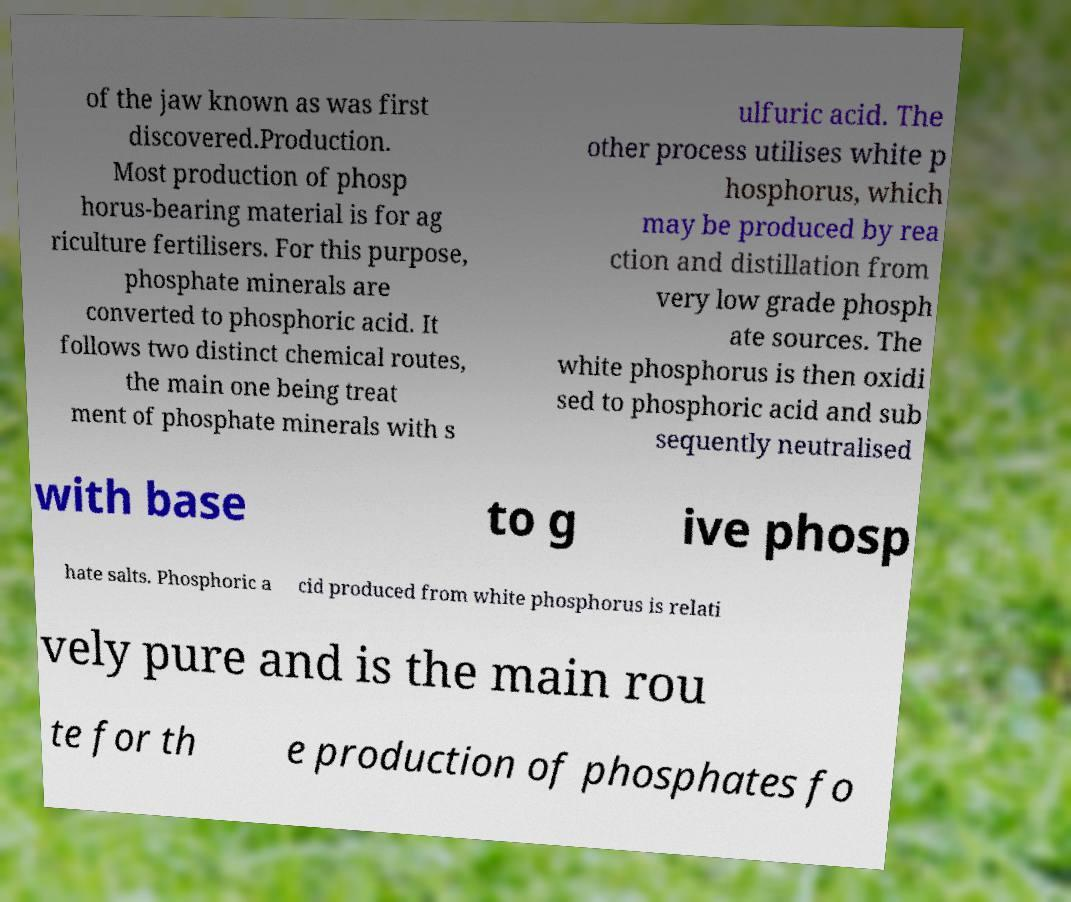There's text embedded in this image that I need extracted. Can you transcribe it verbatim? of the jaw known as was first discovered.Production. Most production of phosp horus-bearing material is for ag riculture fertilisers. For this purpose, phosphate minerals are converted to phosphoric acid. It follows two distinct chemical routes, the main one being treat ment of phosphate minerals with s ulfuric acid. The other process utilises white p hosphorus, which may be produced by rea ction and distillation from very low grade phosph ate sources. The white phosphorus is then oxidi sed to phosphoric acid and sub sequently neutralised with base to g ive phosp hate salts. Phosphoric a cid produced from white phosphorus is relati vely pure and is the main rou te for th e production of phosphates fo 